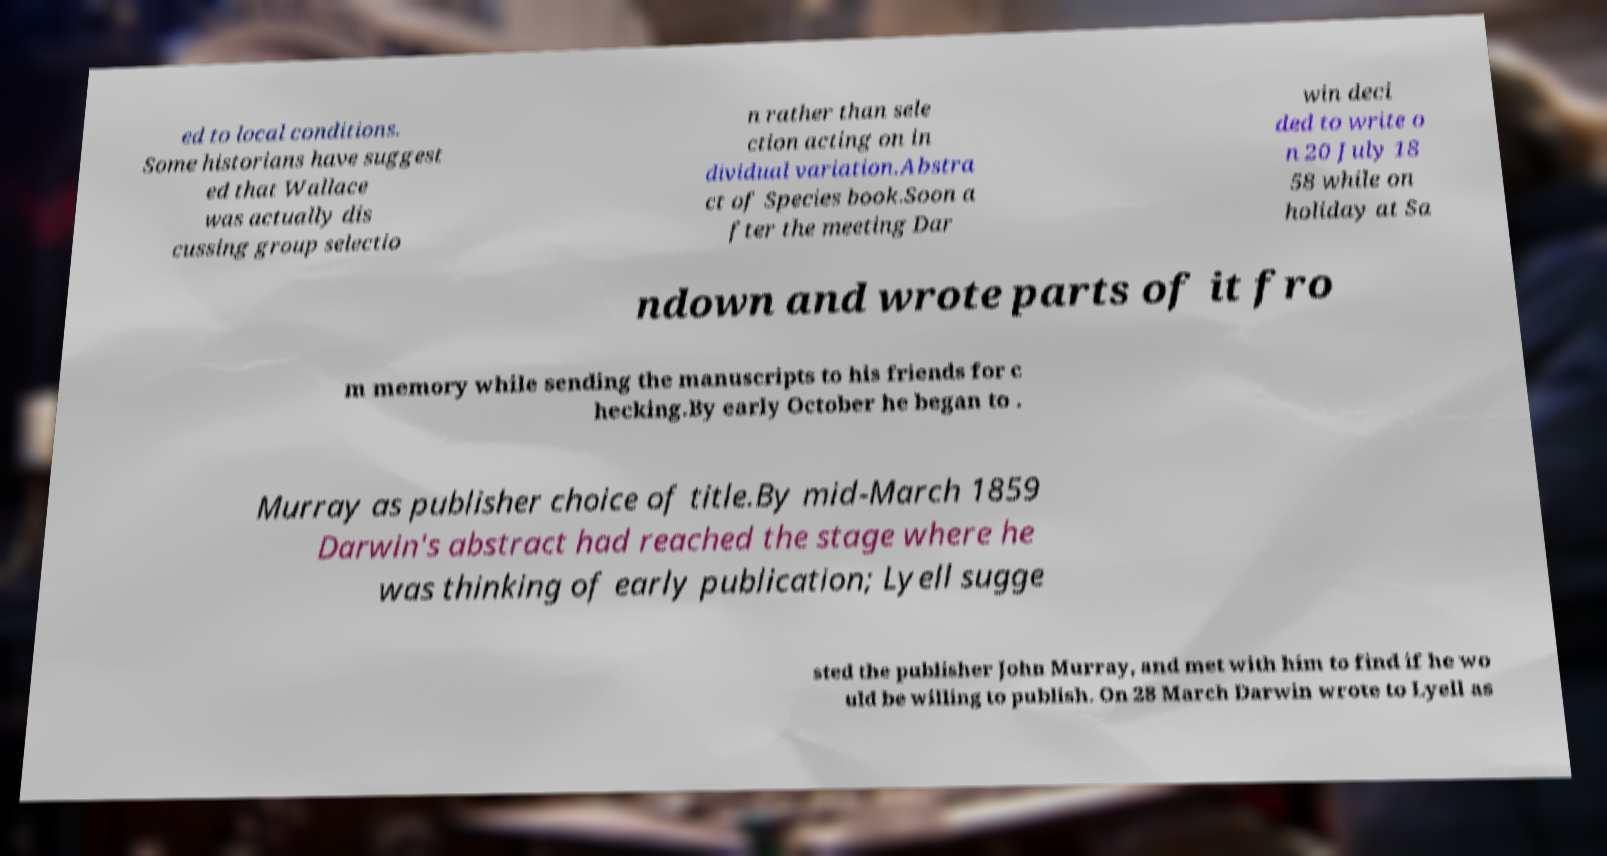Could you extract and type out the text from this image? ed to local conditions. Some historians have suggest ed that Wallace was actually dis cussing group selectio n rather than sele ction acting on in dividual variation.Abstra ct of Species book.Soon a fter the meeting Dar win deci ded to write o n 20 July 18 58 while on holiday at Sa ndown and wrote parts of it fro m memory while sending the manuscripts to his friends for c hecking.By early October he began to . Murray as publisher choice of title.By mid-March 1859 Darwin's abstract had reached the stage where he was thinking of early publication; Lyell sugge sted the publisher John Murray, and met with him to find if he wo uld be willing to publish. On 28 March Darwin wrote to Lyell as 